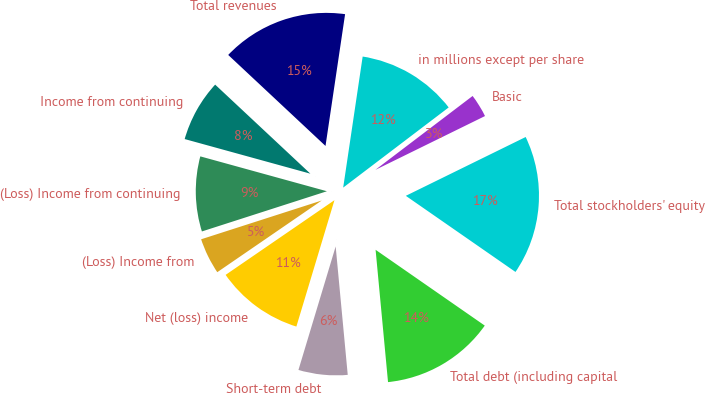Convert chart to OTSL. <chart><loc_0><loc_0><loc_500><loc_500><pie_chart><fcel>in millions except per share<fcel>Total revenues<fcel>Income from continuing<fcel>(Loss) Income from continuing<fcel>(Loss) Income from<fcel>Net (loss) income<fcel>Short-term debt<fcel>Total debt (including capital<fcel>Total stockholders' equity<fcel>Basic<nl><fcel>12.31%<fcel>15.38%<fcel>7.69%<fcel>9.23%<fcel>4.62%<fcel>10.77%<fcel>6.15%<fcel>13.85%<fcel>16.92%<fcel>3.08%<nl></chart> 